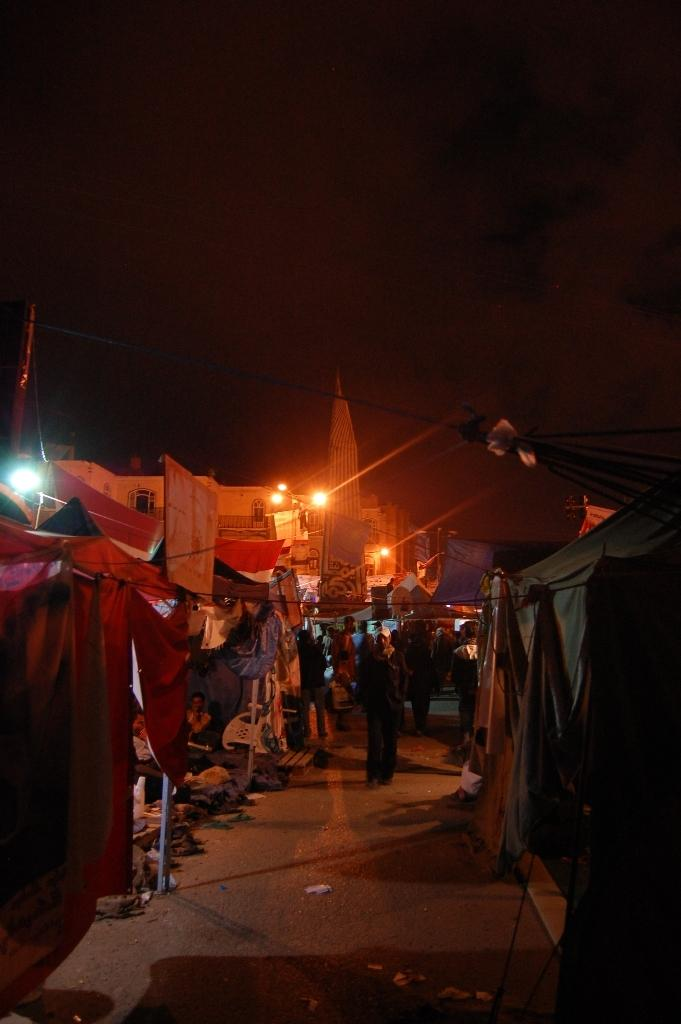What type of structures can be seen in the image? There are stalls and buildings in the image. What can be observed in the image that provides illumination? There are lights in the image. What are the ropes used for in the image? The purpose of the ropes in the image is not specified, but they may be used for various purposes such as tying or hanging objects. How many people are present in the image? There are people in the image. What is on the ground in the image? There are objects on the ground in the image. What is visible in the background of the image? The sky is visible in the background of the image. Can you tell me how many cabbages are being used as a volleyball in the image? There is no cabbage or volleyball present in the image. What is the value of the quarter on the ground in the image? There is no mention of a quarter in the image, so its value cannot be determined. 